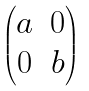Convert formula to latex. <formula><loc_0><loc_0><loc_500><loc_500>\begin{pmatrix} a & 0 \\ 0 & b \end{pmatrix}</formula> 